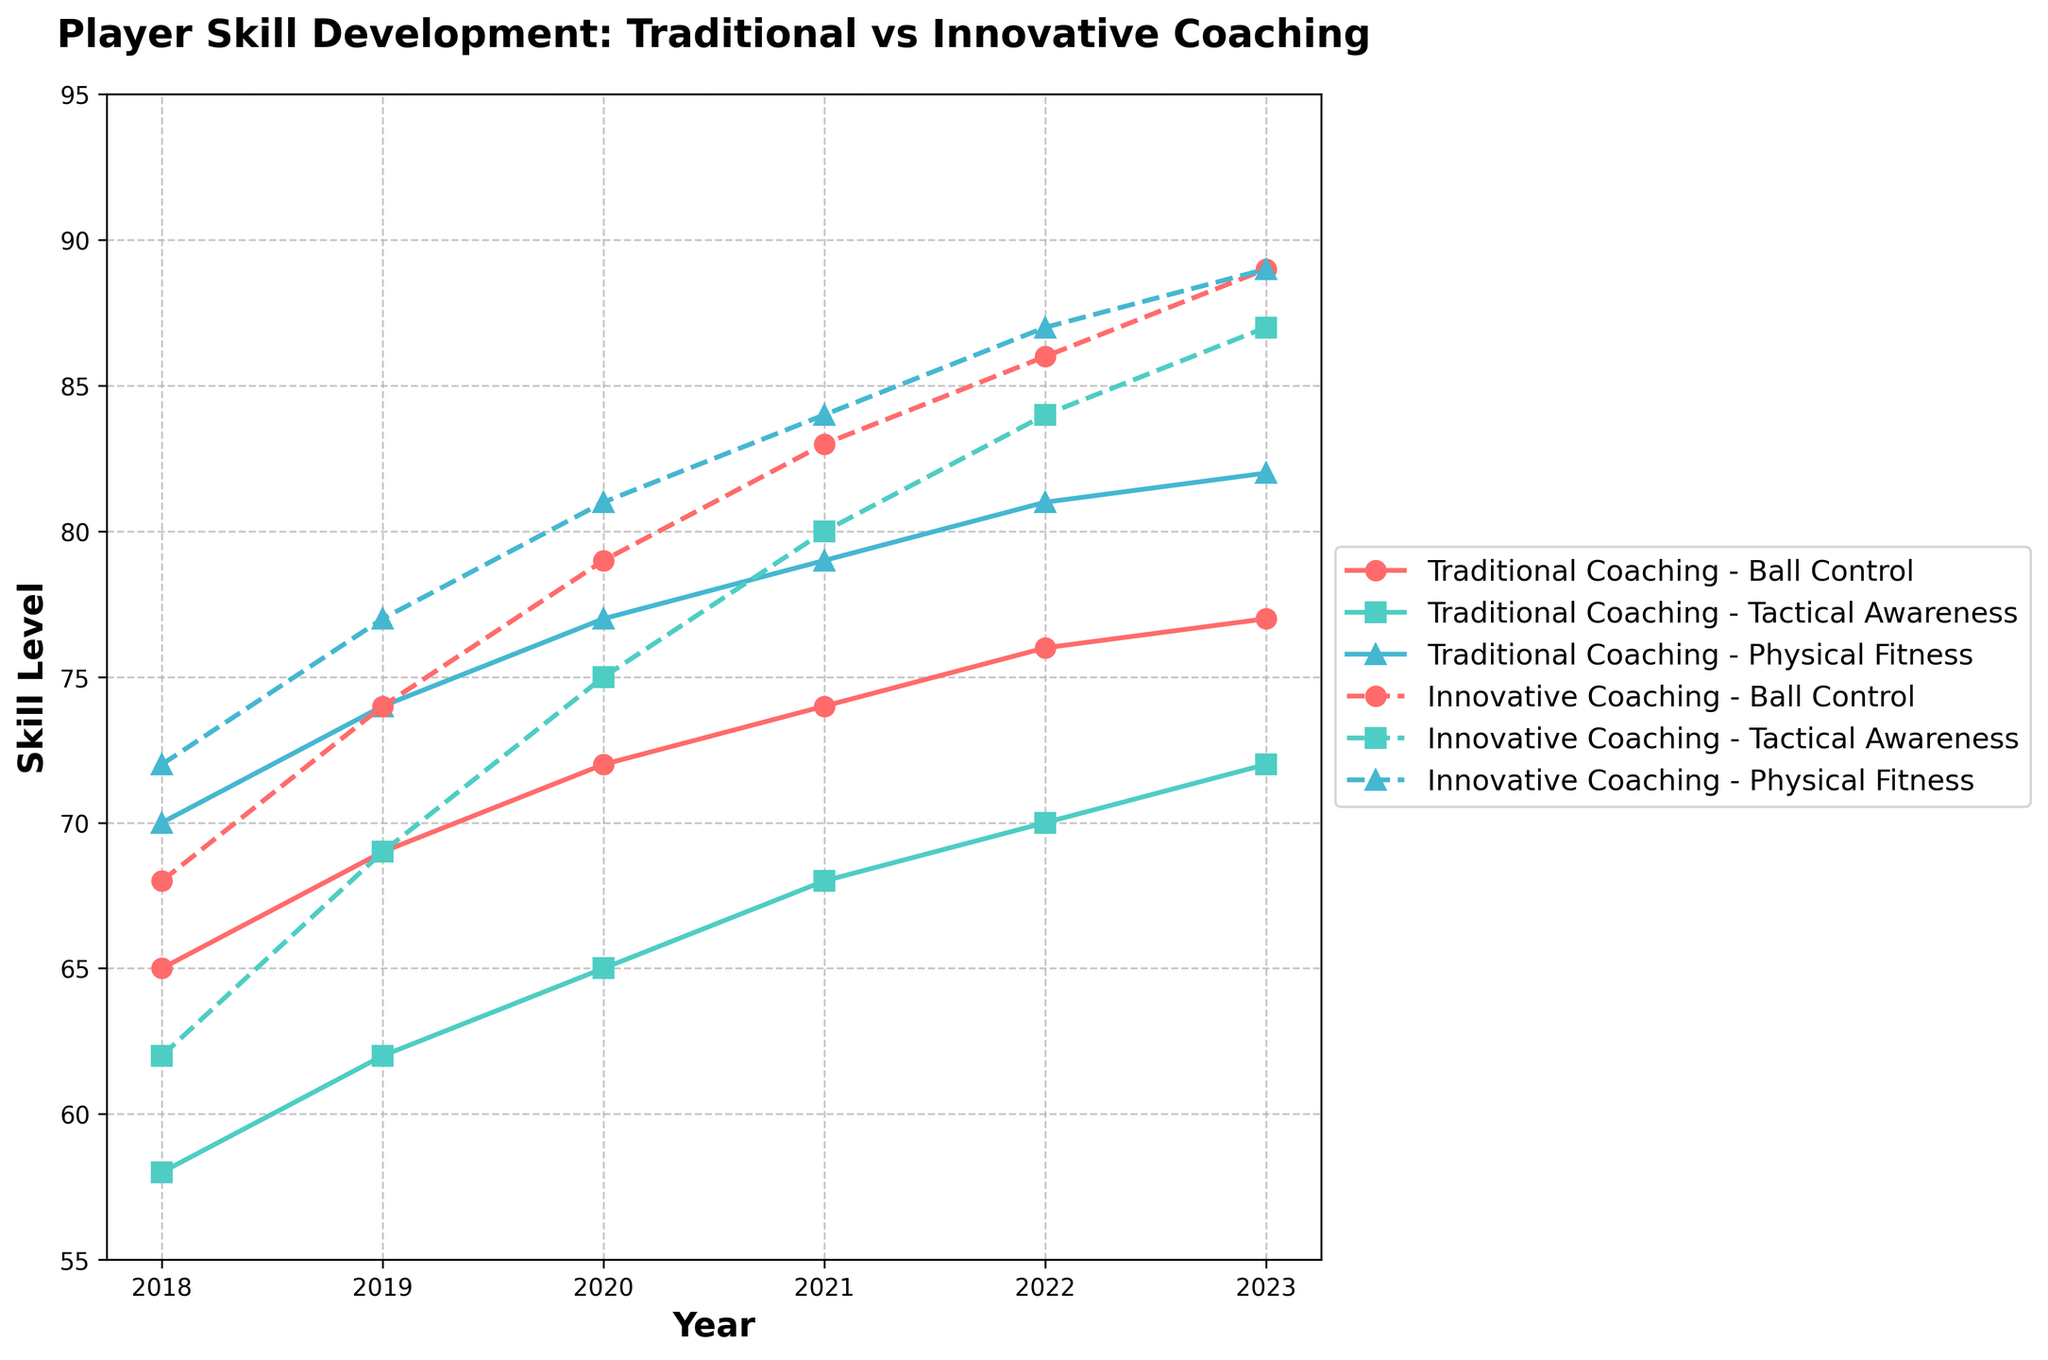Which year saw the biggest improvement in Ball Control for players under Traditional Coaching? To determine the year with the biggest improvement in Ball Control under Traditional Coaching, we need to find the year-over-year changes and identify the largest increase. From 2018 to 2019, the change is 69 - 65 = 4. From 2019 to 2020, the change is 72 - 69 = 3. From 2020 to 2021, the change is 74 - 72 = 2. From 2021 to 2022, the change is 76 - 74 = 2. From 2022 to 2023, the change is 77 - 76 = 1. The year with the largest increase is from 2018 to 2019 with an improvement of 4.
Answer: 2019 Which coaching method showed higher Tactical Awareness improvement by 2023? To compare the improvement in Tactical Awareness, we consider the start and end values of Traditional and Innovative Coaching. For Traditional Coaching, the improvement is from 58 in 2018 to 72 in 2023, a 14-point increase. For Innovative Coaching, the improvement is from 62 in 2018 to 87 in 2023, a 25-point increase. Innovative Coaching showed a higher improvement.
Answer: Innovative Coaching By how much does the Physical Fitness of players under Innovative Coaching exceed that under Traditional Coaching in 2023? To find the excess, we subtract the Physical Fitness value of Traditional Coaching from that of Innovative Coaching for 2023. The value for Innovative Coaching is 89 and for Traditional Coaching is 82. The difference is 89 - 82 = 7.
Answer: 7 What is the total combined Ball Control score for all years under Traditional Coaching? To find the total, we sum the Ball Control scores for all years under Traditional Coaching: 65 + 69 + 72 + 74 + 76 + 77 = 433.
Answer: 433 In which year did players under Innovative Coaching surpass players under Traditional Coaching in Physical Fitness? We need to identify the first year when the Physical Fitness score of Innovative Coaching exceeds that of Traditional Coaching. In 2018, Innovative Coaching is 72 and Traditional is 70. In 2019, Innovative is 77 and Traditional is 74. The first occurrence is in 2018.
Answer: 2018 What is the average Tactical Awareness score for players under Innovative Coaching from 2020 to 2023? To find the average, we sum the scores from 2020 to 2023 and divide by the number of years: (75 + 80 + 84 + 87) / 4 = 326 / 4 = 81.5.
Answer: 81.5 How does the gap in Ball Control between Traditional and Innovative Coaching change from 2018 to 2023? To calculate the initial and final gaps, subtract Traditional from Innovative values for Ball Control in 2018 and 2023. Initial gap in 2018: 68 - 65 = 3. Final gap in 2023: 89 - 77 = 12. Change in gap: 12 - 3 = 9. The gap increased by 9.
Answer: 9 Which skill saw the least improvement under Traditional Coaching from 2018 to 2023? We calculate the improvement for each skill under Traditional Coaching. Ball Control improved from 65 to 77: 77 - 65 = 12. Tactical Awareness improved from 58 to 72: 72 - 58 = 14. Physical Fitness improved from 70 to 82: 82 - 70 = 12. Both Ball Control and Physical Fitness saw the least improvement, each improving by 12.
Answer: Ball Control and Physical Fitness Summarize the trend in Tactical Awareness under Innovative Coaching. The Tactical Awareness score for Innovative Coaching starts at 62 in 2018 and increases steadily every year, reaching 87 in 2023. This represents a consistent upward trend without any declines.
Answer: Upward trend 